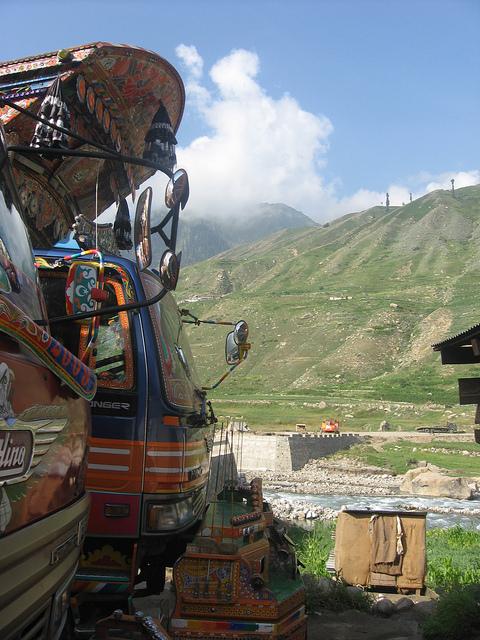What is the color of cloud?
Concise answer only. White. What is the main color of the sky?
Answer briefly. Blue. What is covering the shed?
Answer briefly. Tarp. 